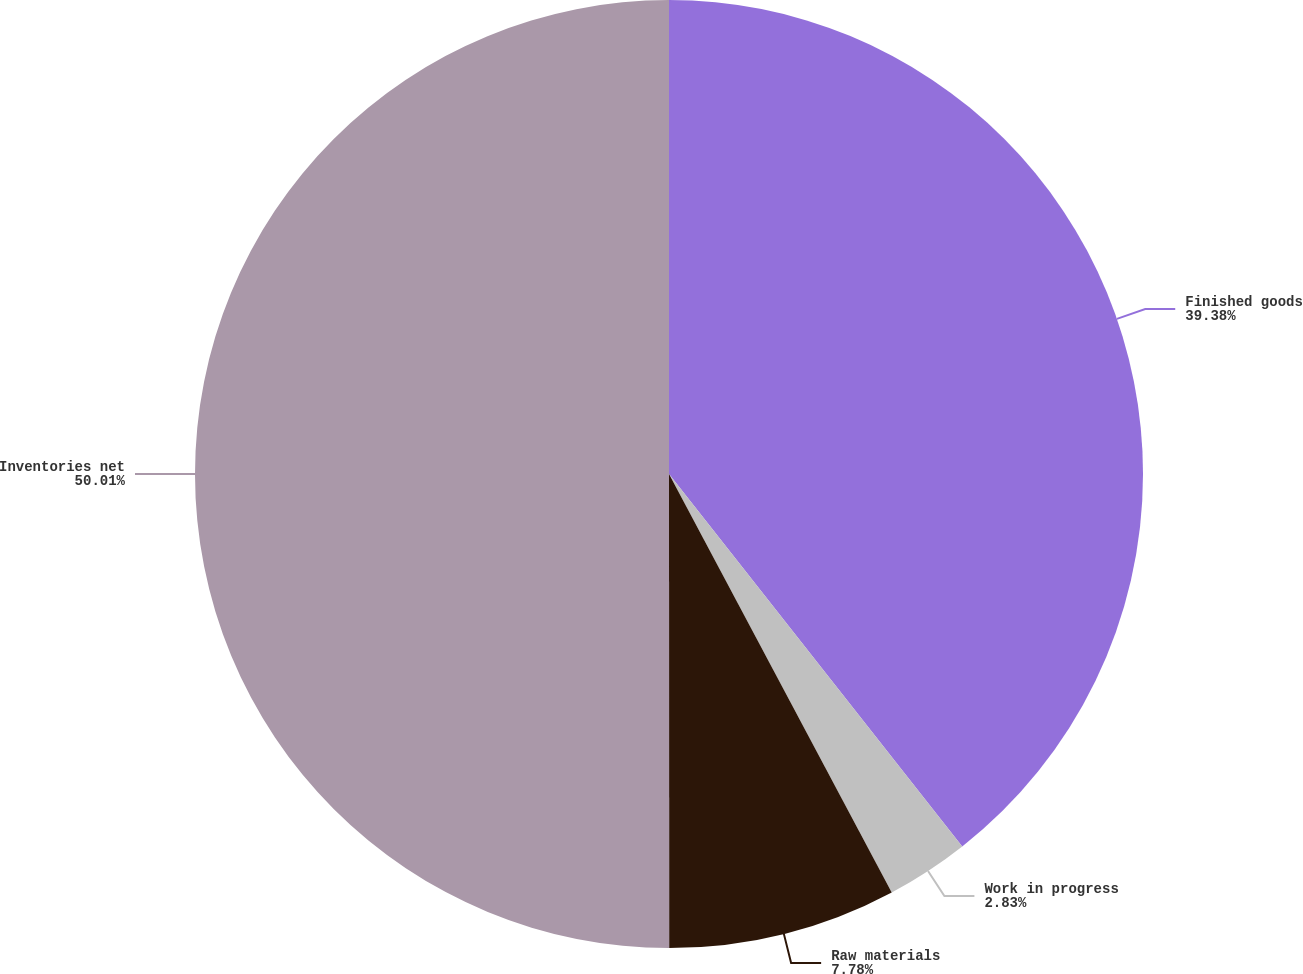Convert chart. <chart><loc_0><loc_0><loc_500><loc_500><pie_chart><fcel>Finished goods<fcel>Work in progress<fcel>Raw materials<fcel>Inventories net<nl><fcel>39.38%<fcel>2.83%<fcel>7.78%<fcel>50.0%<nl></chart> 